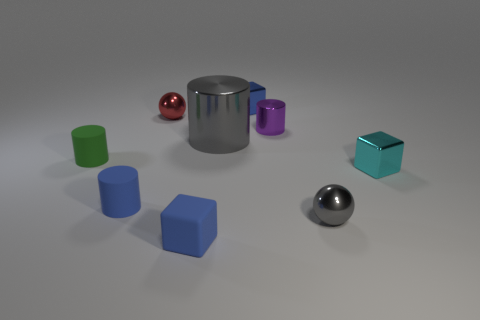What number of purple metal objects are the same size as the blue metal cube?
Ensure brevity in your answer.  1. There is a matte cylinder that is the same color as the rubber block; what size is it?
Your answer should be very brief. Small. The shiny object left of the blue block that is in front of the small gray thing is what color?
Offer a terse response. Red. Are there any tiny objects of the same color as the tiny shiny cylinder?
Your response must be concise. No. What color is the metal cylinder that is the same size as the cyan metallic block?
Offer a very short reply. Purple. Is the block on the right side of the small shiny cylinder made of the same material as the small blue cylinder?
Provide a short and direct response. No. Are there any tiny metal cylinders on the right side of the tiny object that is in front of the tiny metal thing that is in front of the small cyan thing?
Offer a terse response. Yes. Do the blue object behind the small green cylinder and the small purple metal object have the same shape?
Ensure brevity in your answer.  No. What is the shape of the gray object on the right side of the blue object behind the purple cylinder?
Offer a very short reply. Sphere. There is a metallic ball that is behind the purple cylinder right of the matte cylinder behind the small cyan cube; what is its size?
Ensure brevity in your answer.  Small. 